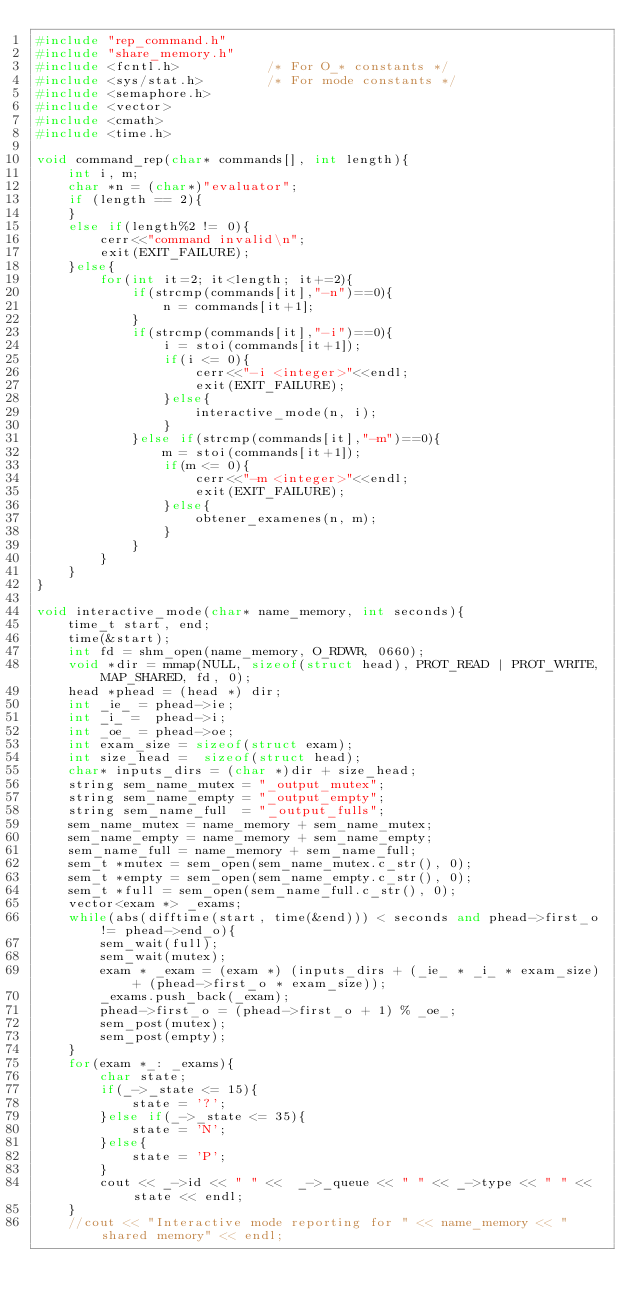Convert code to text. <code><loc_0><loc_0><loc_500><loc_500><_C++_>#include "rep_command.h"
#include "share_memory.h"
#include <fcntl.h>           /* For O_* constants */
#include <sys/stat.h>        /* For mode constants */
#include <semaphore.h>
#include <vector>
#include <cmath>
#include <time.h>

void command_rep(char* commands[], int length){
    int i, m;
    char *n = (char*)"evaluator";
    if (length == 2){
    }
    else if(length%2 != 0){
        cerr<<"command invalid\n";
        exit(EXIT_FAILURE);
    }else{
        for(int it=2; it<length; it+=2){
            if(strcmp(commands[it],"-n")==0){
                n = commands[it+1];
            }
            if(strcmp(commands[it],"-i")==0){
                i = stoi(commands[it+1]);
                if(i <= 0){
                    cerr<<"-i <integer>"<<endl;
                    exit(EXIT_FAILURE);
                }else{
                    interactive_mode(n, i);
                } 
            }else if(strcmp(commands[it],"-m")==0){
                m = stoi(commands[it+1]);
                if(m <= 0){
                    cerr<<"-m <integer>"<<endl;
                    exit(EXIT_FAILURE);
                }else{
                    obtener_examenes(n, m);
                } 
            }
        }
    }
}

void interactive_mode(char* name_memory, int seconds){
    time_t start, end;
    time(&start);
    int fd = shm_open(name_memory, O_RDWR, 0660);
    void *dir = mmap(NULL, sizeof(struct head), PROT_READ | PROT_WRITE, MAP_SHARED, fd, 0);
    head *phead = (head *) dir;
    int _ie_ = phead->ie;
    int _i_ =  phead->i;
    int _oe_ = phead->oe;
    int exam_size = sizeof(struct exam);
    int size_head =  sizeof(struct head);
    char* inputs_dirs = (char *)dir + size_head;
    string sem_name_mutex = "_output_mutex";
    string sem_name_empty = "_output_empty";
    string sem_name_full  = "_output_fulls"; 
    sem_name_mutex = name_memory + sem_name_mutex;
    sem_name_empty = name_memory + sem_name_empty;
    sem_name_full = name_memory + sem_name_full;
    sem_t *mutex = sem_open(sem_name_mutex.c_str(), 0);
    sem_t *empty = sem_open(sem_name_empty.c_str(), 0);
    sem_t *full = sem_open(sem_name_full.c_str(), 0);
    vector<exam *> _exams;
    while(abs(difftime(start, time(&end))) < seconds and phead->first_o != phead->end_o){
        sem_wait(full);
        sem_wait(mutex);
        exam * _exam = (exam *) (inputs_dirs + (_ie_ * _i_ * exam_size) + (phead->first_o * exam_size));
        _exams.push_back(_exam);
        phead->first_o = (phead->first_o + 1) % _oe_;
        sem_post(mutex);
        sem_post(empty);
    }
    for(exam *_: _exams){
        char state;
        if(_->_state <= 15){
            state = '?';
        }else if(_->_state <= 35){
            state = 'N';
        }else{
            state = 'P';
        }
        cout << _->id << " " <<  _->_queue << " " << _->type << " " << state << endl;
    }
    //cout << "Interactive mode reporting for " << name_memory << " shared memory" << endl;</code> 